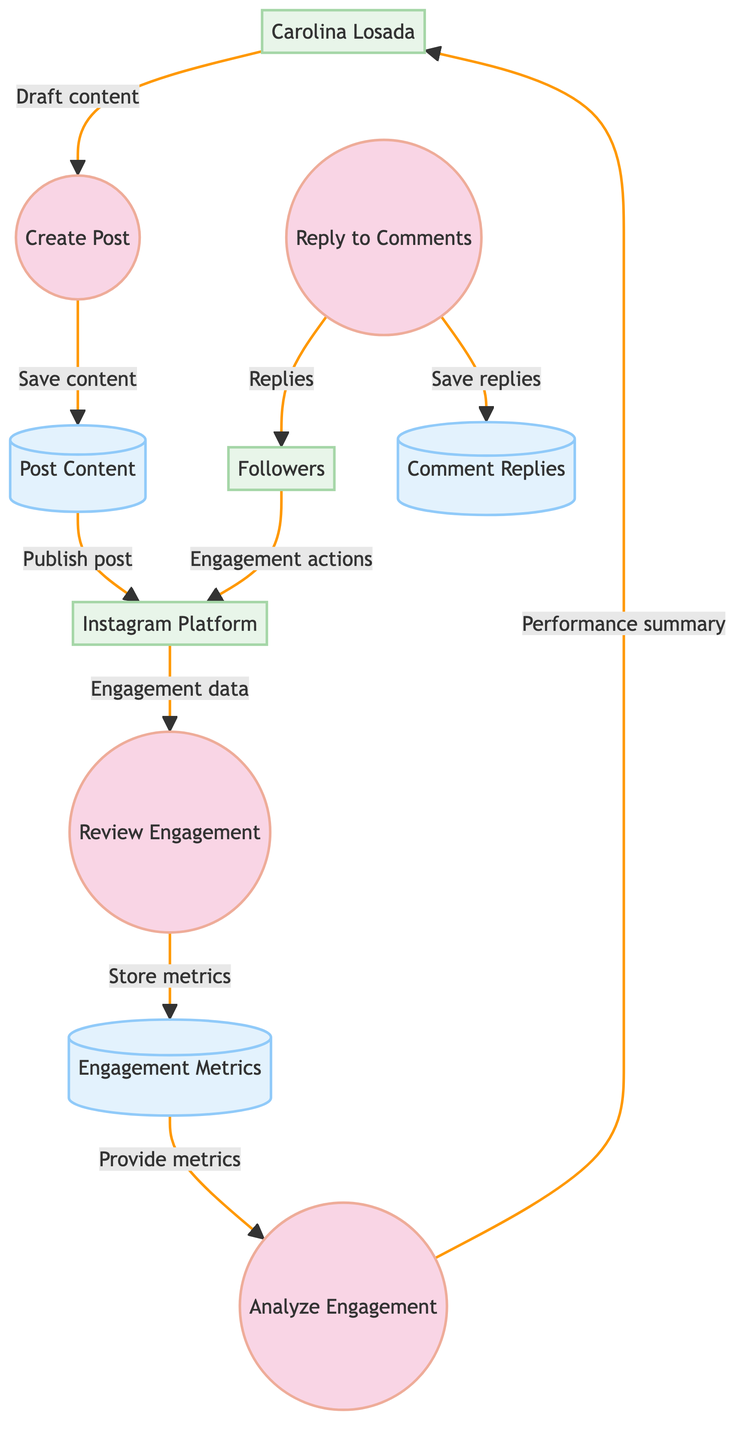What is the first process in the workflow? The first process is identified by the label "Create Post," which is the initial stage in the workflow where Carolina Losada and her team draft a new Instagram post.
Answer: Create Post How many processes are there in the diagram? Upon examining the diagram, we can count four distinct processes labeled as "Create Post," "Review Engagement," "Reply to Comments," and "Analyze Engagement."
Answer: Four What data store receives engagement metrics? The data store that receives engagement metrics is labeled "Engagement Metrics," which stores data related to likes, comments, shares, and engagement actions.
Answer: Engagement Metrics Who is responsible for replying to comments? The process labeled "Reply to Comments" indicates that replies to followers' comments are handled through this specific workflow stage.
Answer: Reply to Comments Which external entity contributes engagement actions? The external entity "Followers" contributes engagement actions, such as likes, comments, and shares, directed to the Instagram platform.
Answer: Followers What data flow connects the "Analyze Engagement" process to Carolina Losada? The data flow labeled "Summary of post performance" connects the "Analyze Engagement" process to Carolina Losada, providing her with insights on the post's performance.
Answer: Summary of post performance From which data store does the "Analyze Engagement" process receive information? The "Analyze Engagement" process receives information from the "Engagement Metrics" data store, which provides relevant engagement data for performance assessment.
Answer: Engagement Metrics What is stored in the "Comment Replies" data store? The "Comment Replies" data store archives the replies made to followers' comments, which are generated during the engagement workflow.
Answer: Replies to followers' comments 